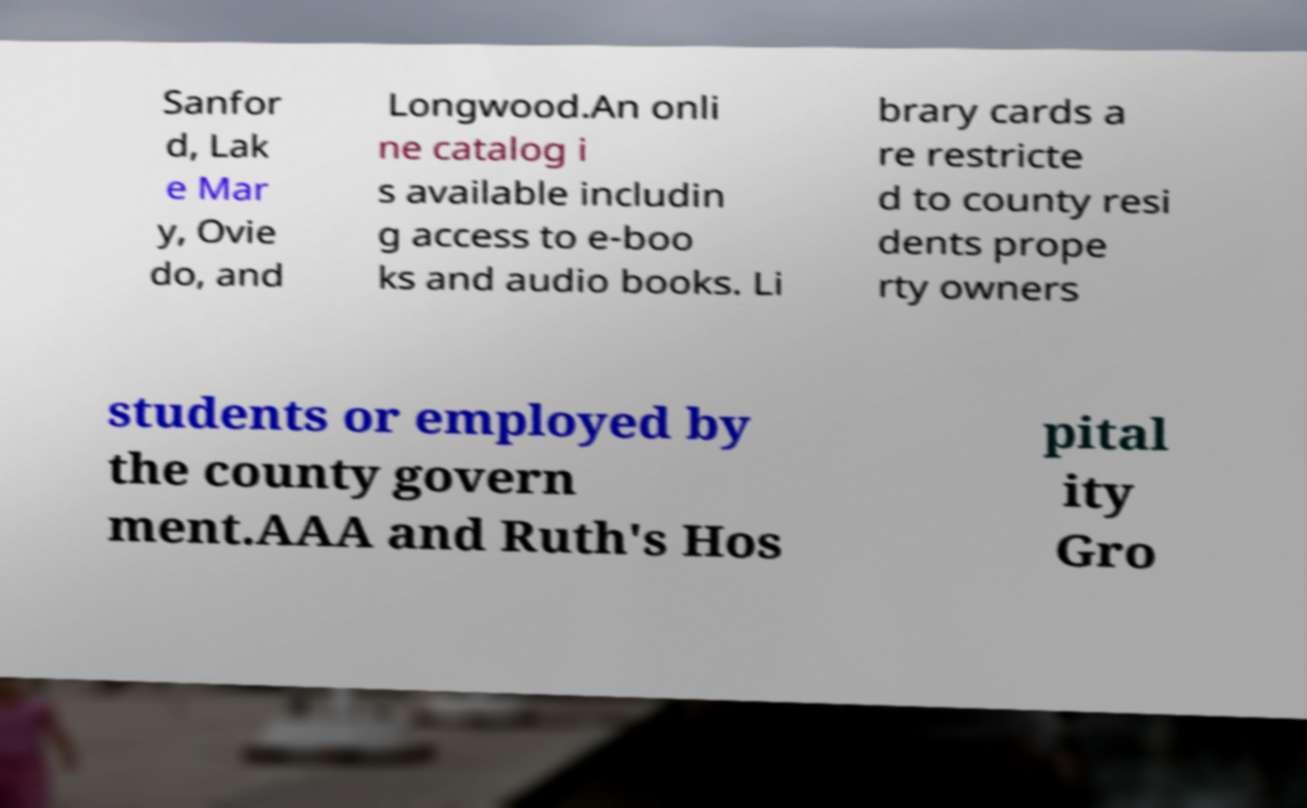I need the written content from this picture converted into text. Can you do that? Sanfor d, Lak e Mar y, Ovie do, and Longwood.An onli ne catalog i s available includin g access to e-boo ks and audio books. Li brary cards a re restricte d to county resi dents prope rty owners students or employed by the county govern ment.AAA and Ruth's Hos pital ity Gro 